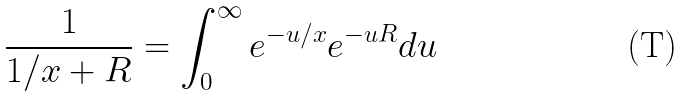<formula> <loc_0><loc_0><loc_500><loc_500>\frac { 1 } { 1 / x + R } = \int _ { 0 } ^ { \infty } e ^ { - u / x } e ^ { - u R } d u</formula> 